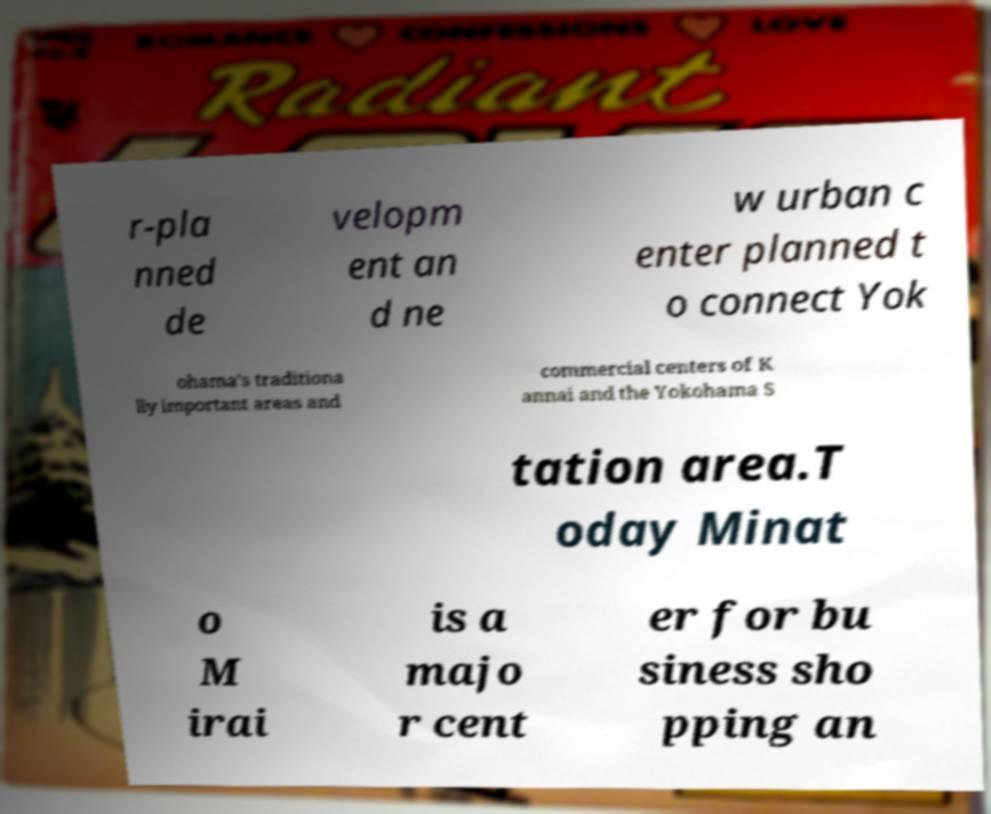For documentation purposes, I need the text within this image transcribed. Could you provide that? r-pla nned de velopm ent an d ne w urban c enter planned t o connect Yok ohama's traditiona lly important areas and commercial centers of K annai and the Yokohama S tation area.T oday Minat o M irai is a majo r cent er for bu siness sho pping an 